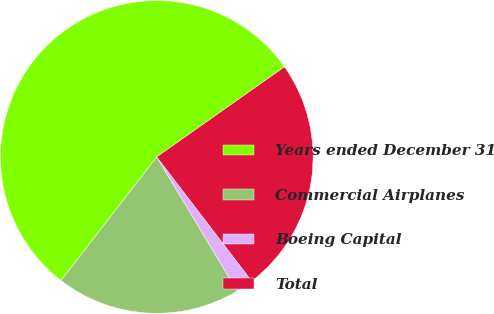<chart> <loc_0><loc_0><loc_500><loc_500><pie_chart><fcel>Years ended December 31<fcel>Commercial Airplanes<fcel>Boeing Capital<fcel>Total<nl><fcel>54.74%<fcel>19.08%<fcel>1.8%<fcel>24.38%<nl></chart> 